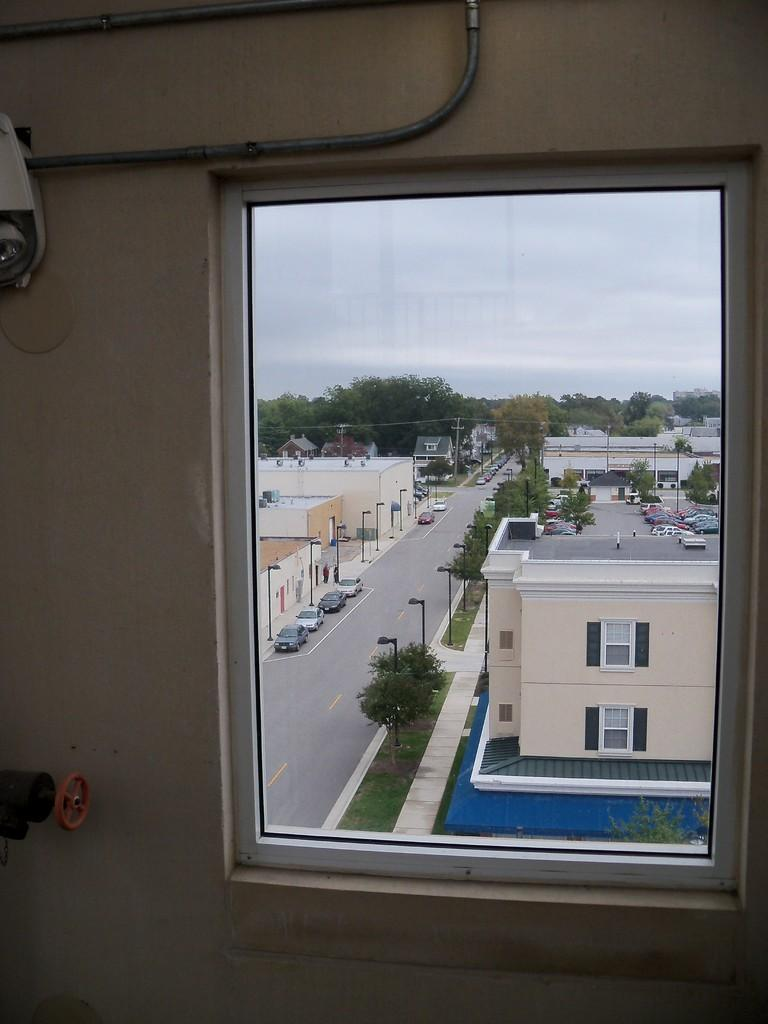What type of structure can be seen in the image? There is a wall in the image. What feature is present in the wall? There is a window in the image. What can be seen in the background of the image? There are buildings visible in the image. What type of natural elements are present in the image? Trees are present in the image. What type of transportation is visible in the image? Vehicles are on the road in the image. What part of the natural environment is visible in the image? The sky is visible in the image. How many hands can be seen holding the trees in the image? There are no hands holding the trees in the image; trees are a natural element and do not require human assistance. 